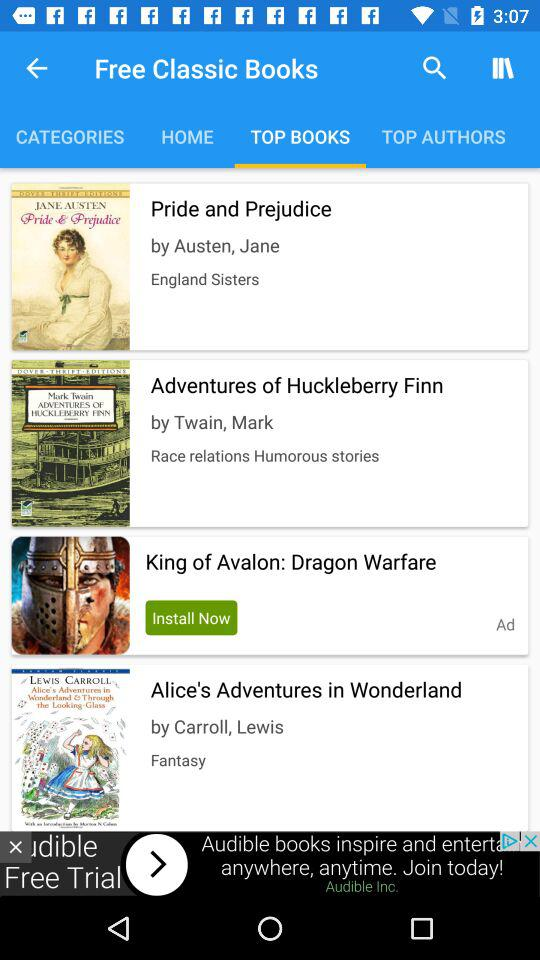Which tab am I on? You are on the "TOP BOOKS" tab. 